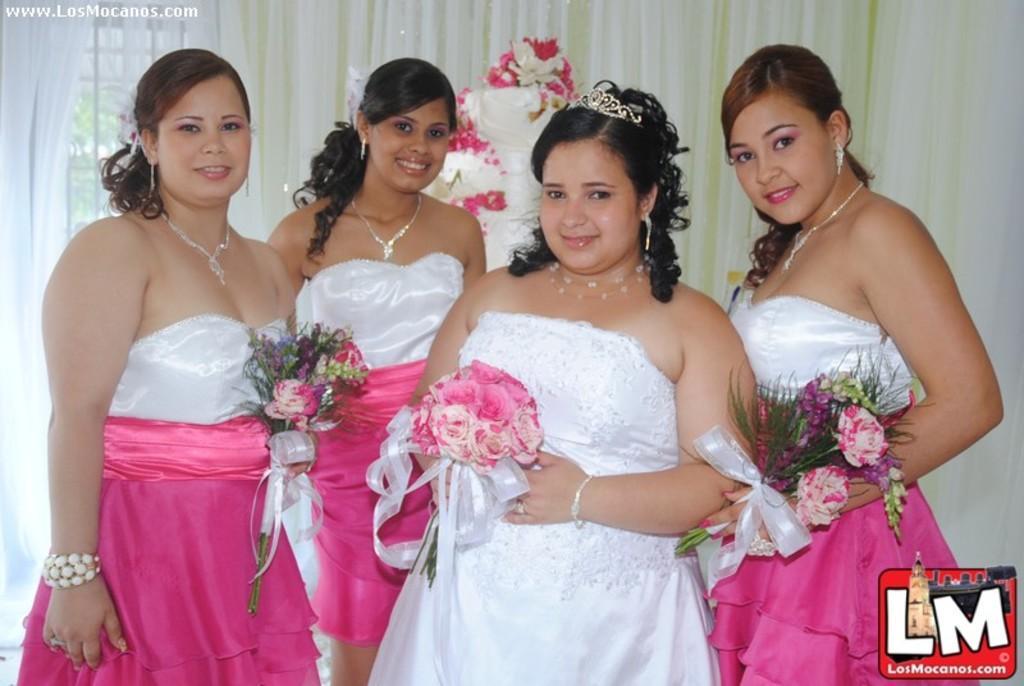Could you give a brief overview of what you see in this image? Here in this picture we can see a group of women standing over a place and all of them are holding flower bouquets and smiling over there and behind them we can see a curtain and we can see some decoration present over there. 